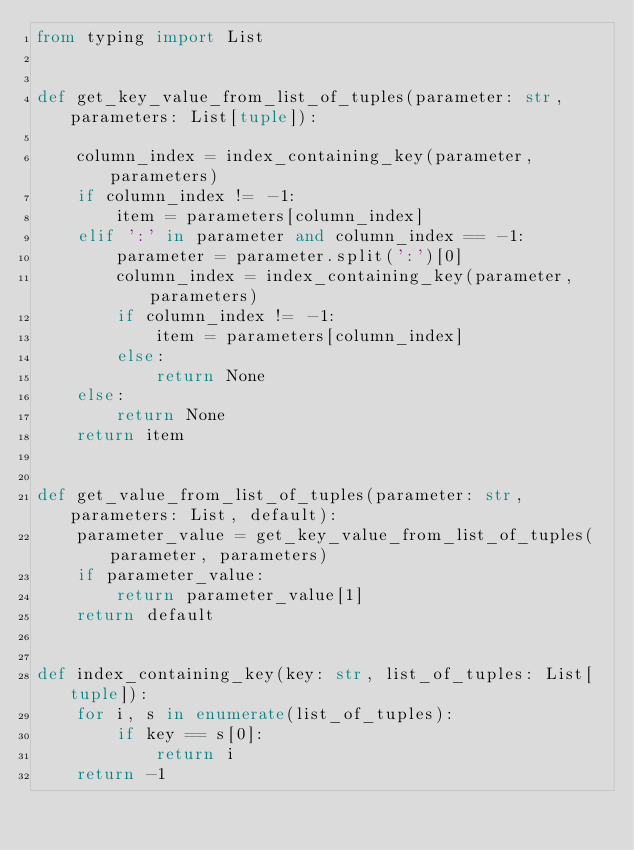<code> <loc_0><loc_0><loc_500><loc_500><_Python_>from typing import List


def get_key_value_from_list_of_tuples(parameter: str, parameters: List[tuple]):

    column_index = index_containing_key(parameter, parameters)
    if column_index != -1:
        item = parameters[column_index]
    elif ':' in parameter and column_index == -1:
        parameter = parameter.split(':')[0]
        column_index = index_containing_key(parameter, parameters)
        if column_index != -1:
            item = parameters[column_index]
        else:
            return None
    else:
        return None
    return item


def get_value_from_list_of_tuples(parameter: str, parameters: List, default):
    parameter_value = get_key_value_from_list_of_tuples(parameter, parameters)
    if parameter_value:
        return parameter_value[1]
    return default


def index_containing_key(key: str, list_of_tuples: List[tuple]):
    for i, s in enumerate(list_of_tuples):
        if key == s[0]:
            return i
    return -1
</code> 